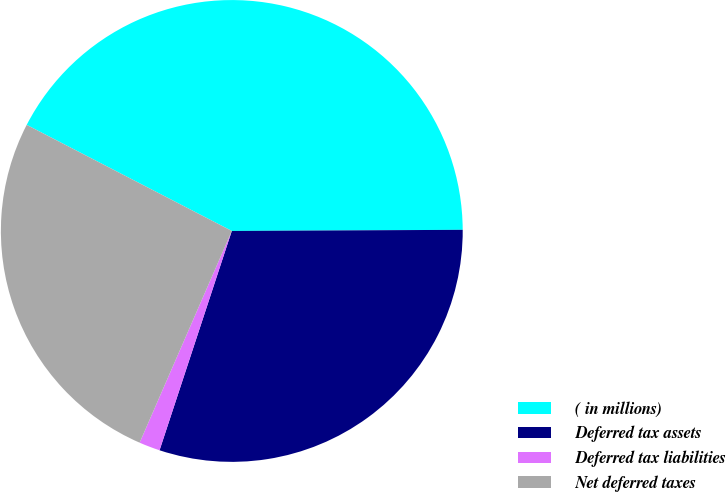<chart> <loc_0><loc_0><loc_500><loc_500><pie_chart><fcel>( in millions)<fcel>Deferred tax assets<fcel>Deferred tax liabilities<fcel>Net deferred taxes<nl><fcel>42.32%<fcel>30.14%<fcel>1.47%<fcel>26.06%<nl></chart> 